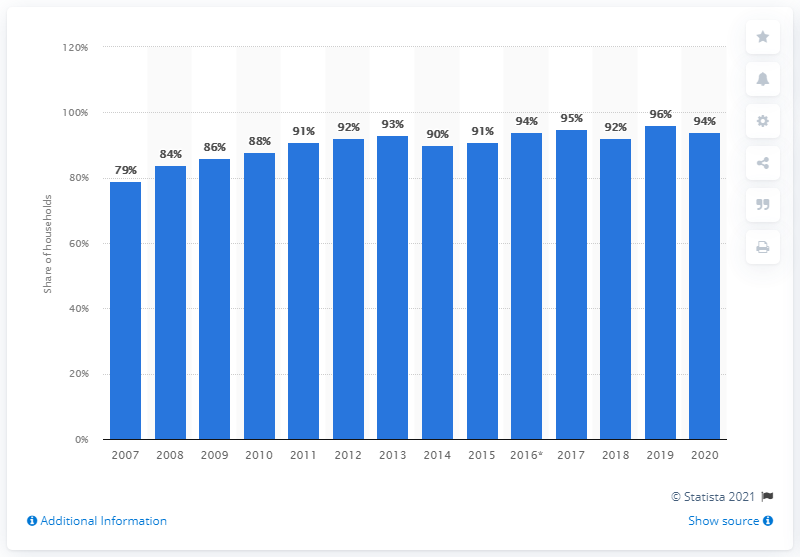Highlight a few significant elements in this photo. In 2020, the share of households in Sweden with internet access was 96%. The peak of internet access in Sweden in the previous year was 96%. 